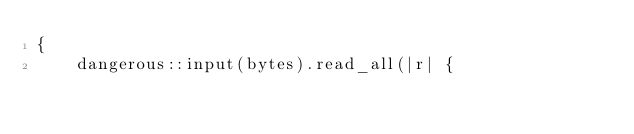Convert code to text. <code><loc_0><loc_0><loc_500><loc_500><_Rust_>{
    dangerous::input(bytes).read_all(|r| {</code> 